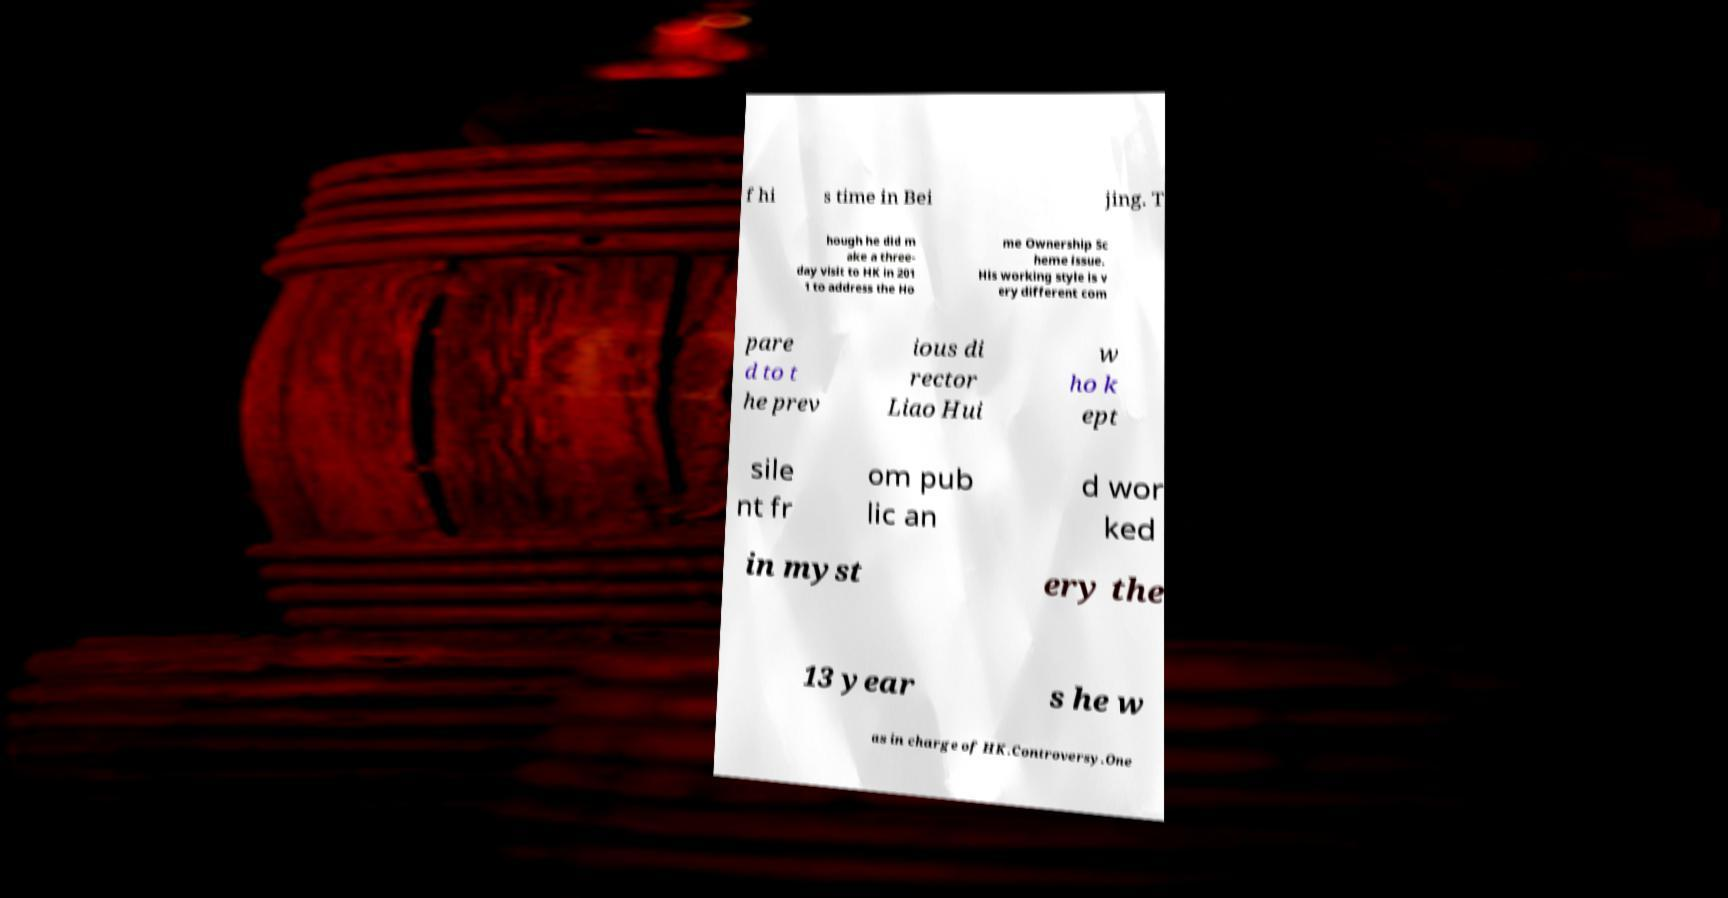Could you extract and type out the text from this image? f hi s time in Bei jing. T hough he did m ake a three- day visit to HK in 201 1 to address the Ho me Ownership Sc heme issue. His working style is v ery different com pare d to t he prev ious di rector Liao Hui w ho k ept sile nt fr om pub lic an d wor ked in myst ery the 13 year s he w as in charge of HK.Controversy.One 